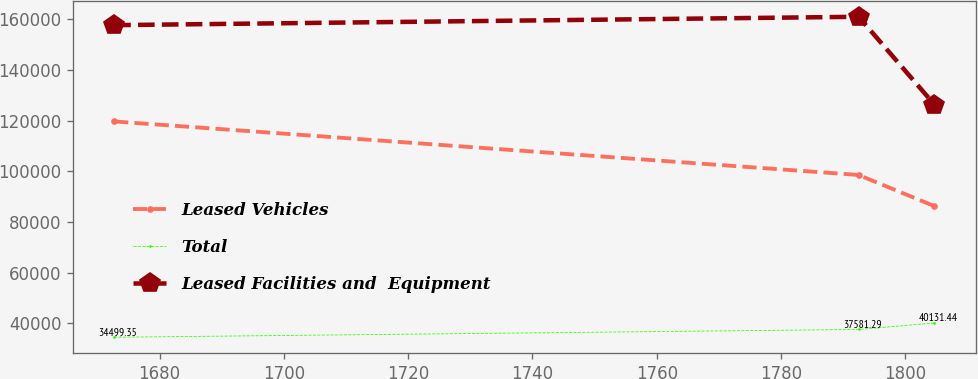Convert chart. <chart><loc_0><loc_0><loc_500><loc_500><line_chart><ecel><fcel>Leased Vehicles<fcel>Total<fcel>Leased Facilities and  Equipment<nl><fcel>1672.68<fcel>119681<fcel>34499.3<fcel>157689<nl><fcel>1792.49<fcel>98554.9<fcel>37581.3<fcel>160992<nl><fcel>1804.7<fcel>86238.1<fcel>40131.4<fcel>126289<nl></chart> 